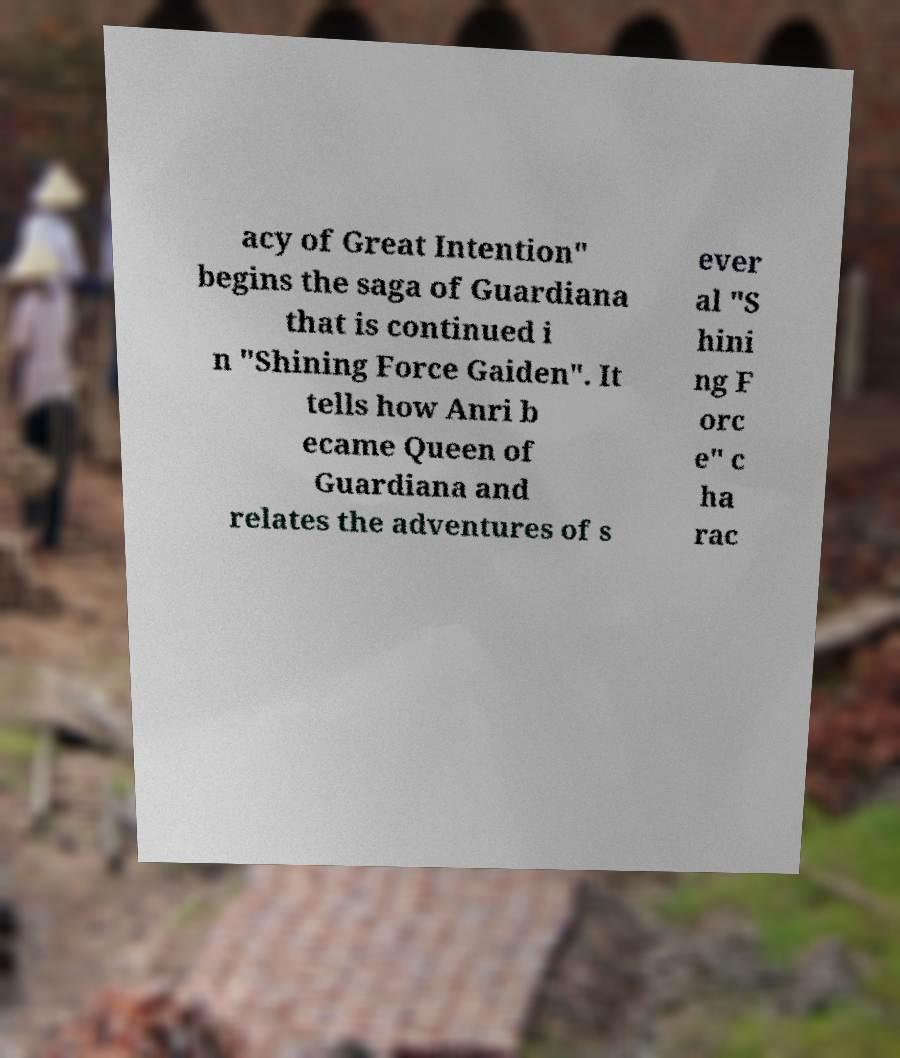Please identify and transcribe the text found in this image. acy of Great Intention" begins the saga of Guardiana that is continued i n "Shining Force Gaiden". It tells how Anri b ecame Queen of Guardiana and relates the adventures of s ever al "S hini ng F orc e" c ha rac 